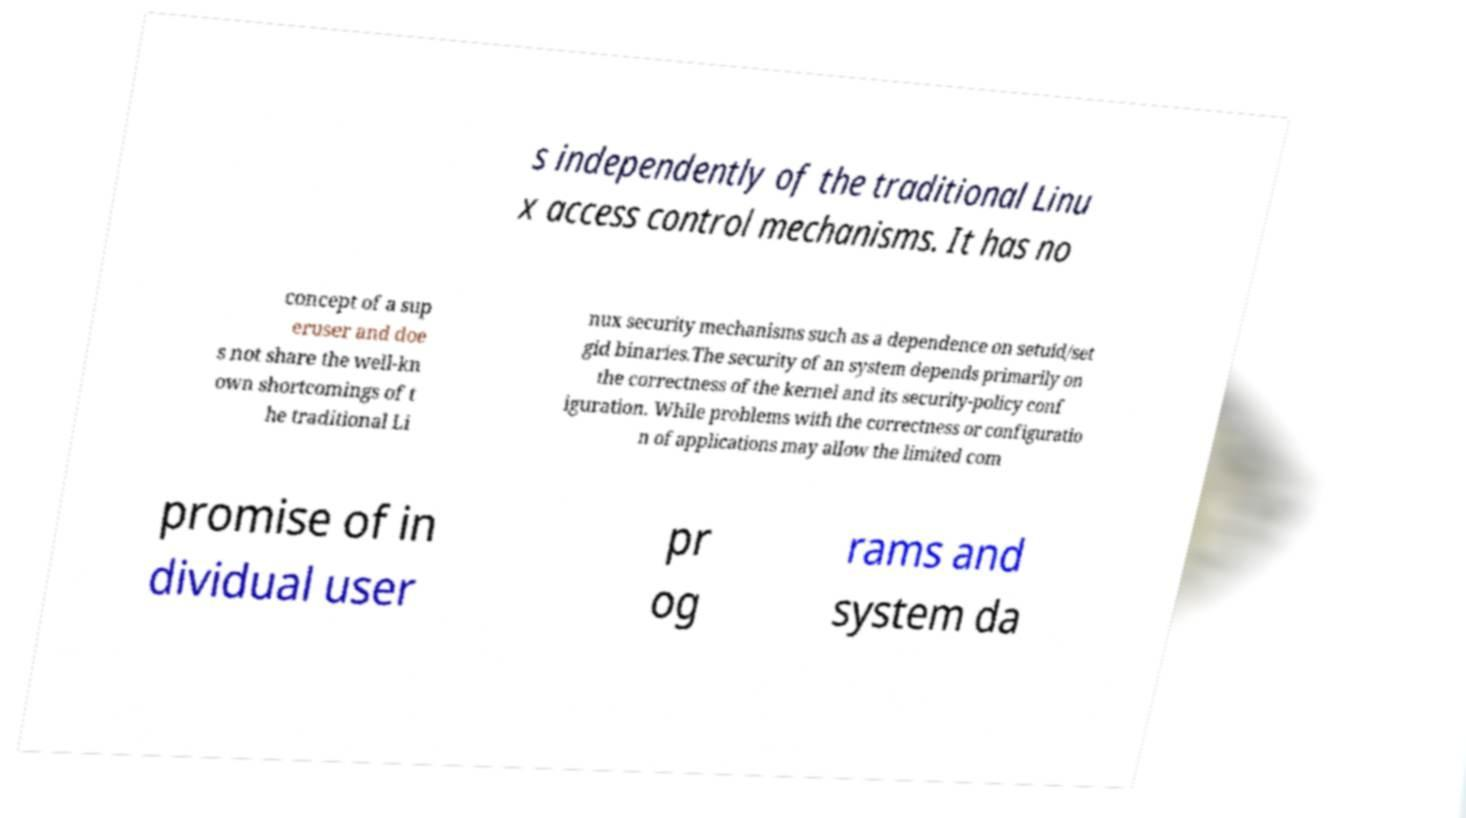I need the written content from this picture converted into text. Can you do that? s independently of the traditional Linu x access control mechanisms. It has no concept of a sup eruser and doe s not share the well-kn own shortcomings of t he traditional Li nux security mechanisms such as a dependence on setuid/set gid binaries.The security of an system depends primarily on the correctness of the kernel and its security-policy conf iguration. While problems with the correctness or configuratio n of applications may allow the limited com promise of in dividual user pr og rams and system da 